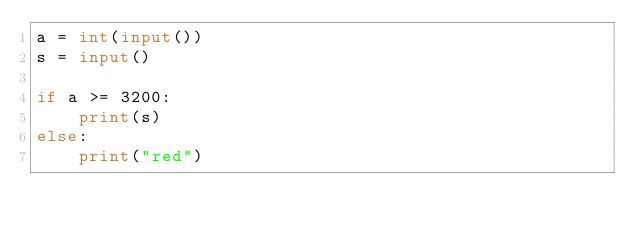Convert code to text. <code><loc_0><loc_0><loc_500><loc_500><_Python_>a = int(input())
s = input()

if a >= 3200:
    print(s)
else:
    print("red")</code> 